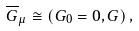<formula> <loc_0><loc_0><loc_500><loc_500>\overline { G } _ { \mu } \cong \left ( G _ { 0 } = 0 , G \right ) ,</formula> 